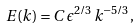Convert formula to latex. <formula><loc_0><loc_0><loc_500><loc_500>E ( k ) = C \, \epsilon ^ { 2 / 3 } \, k ^ { - 5 / 3 } ,</formula> 